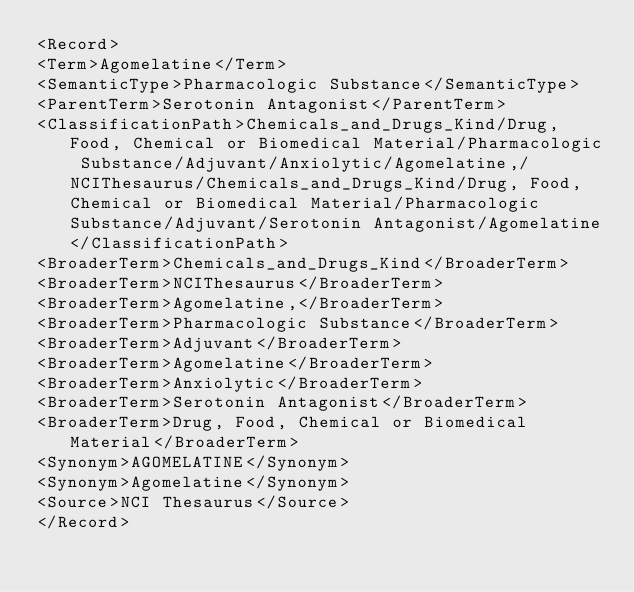Convert code to text. <code><loc_0><loc_0><loc_500><loc_500><_XML_><Record>
<Term>Agomelatine</Term>
<SemanticType>Pharmacologic Substance</SemanticType>
<ParentTerm>Serotonin Antagonist</ParentTerm>
<ClassificationPath>Chemicals_and_Drugs_Kind/Drug, Food, Chemical or Biomedical Material/Pharmacologic Substance/Adjuvant/Anxiolytic/Agomelatine,/NCIThesaurus/Chemicals_and_Drugs_Kind/Drug, Food, Chemical or Biomedical Material/Pharmacologic Substance/Adjuvant/Serotonin Antagonist/Agomelatine</ClassificationPath>
<BroaderTerm>Chemicals_and_Drugs_Kind</BroaderTerm>
<BroaderTerm>NCIThesaurus</BroaderTerm>
<BroaderTerm>Agomelatine,</BroaderTerm>
<BroaderTerm>Pharmacologic Substance</BroaderTerm>
<BroaderTerm>Adjuvant</BroaderTerm>
<BroaderTerm>Agomelatine</BroaderTerm>
<BroaderTerm>Anxiolytic</BroaderTerm>
<BroaderTerm>Serotonin Antagonist</BroaderTerm>
<BroaderTerm>Drug, Food, Chemical or Biomedical Material</BroaderTerm>
<Synonym>AGOMELATINE</Synonym>
<Synonym>Agomelatine</Synonym>
<Source>NCI Thesaurus</Source>
</Record>
</code> 